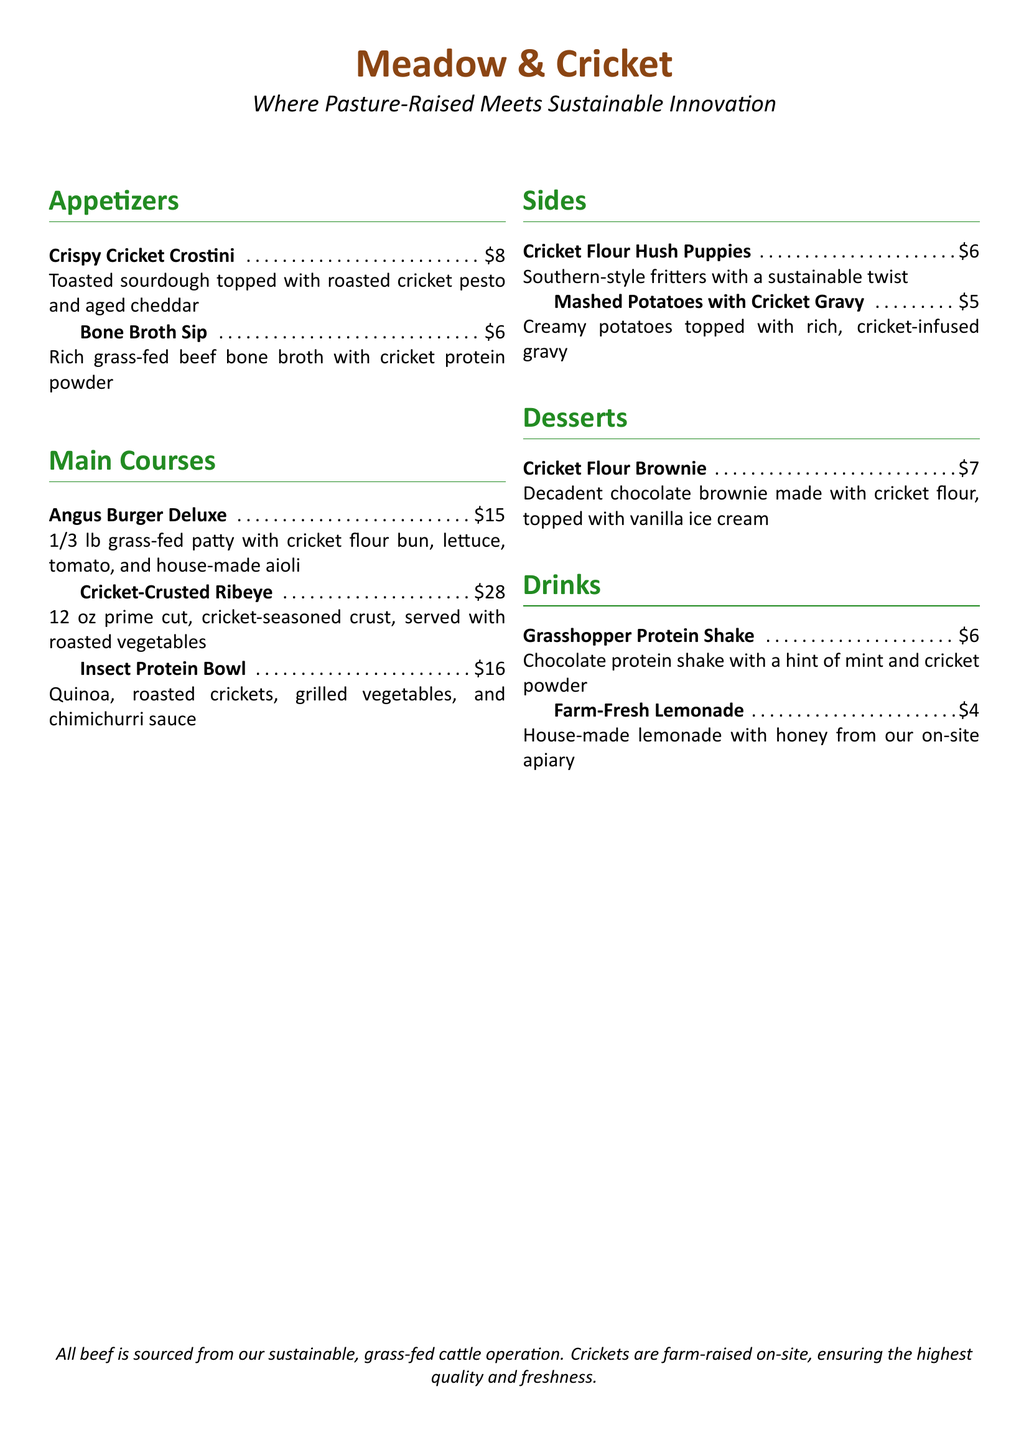What is the name of the restaurant? The name of the restaurant is clearly stated at the top of the document.
Answer: Meadow & Cricket What is the price of the Crispy Cricket Crostini? The price is listed next to the dish in the appetizers section.
Answer: $8 How many ounces is the Cricket-Crusted Ribeye? The ounce measurement is mentioned in the description of the main course.
Answer: 12 oz What type of shake is offered in the drinks section? The shake is specifically named in the menu under the drinks section.
Answer: Grasshopper Protein Shake What ingredient is used in the Cricket Flour Brownie? The key ingredient is highlighted in the dessert section.
Answer: Cricket flour What type of vegetables accompany the Cricket-Crusted Ribeye? The accompanying vegetables are mentioned in the description of the main course.
Answer: Roasted vegetables How much does the Insect Protein Bowl cost? The cost is indicated in the price section next to the dish.
Answer: $16 What is the main protein source in the Bone Broth Sip? The main protein source is detailed in the description of the appetizer.
Answer: Cricket protein powder Which dessert comes with vanilla ice cream? The dessert description explicitly mentions this detail.
Answer: Cricket Flour Brownie 